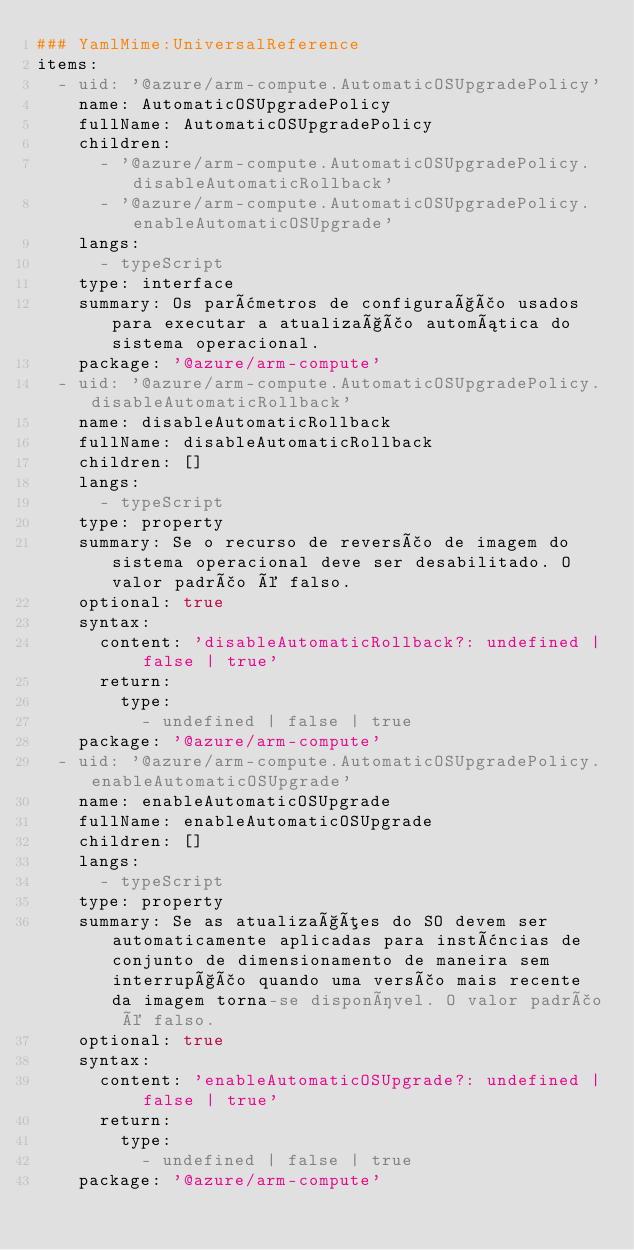<code> <loc_0><loc_0><loc_500><loc_500><_YAML_>### YamlMime:UniversalReference
items:
  - uid: '@azure/arm-compute.AutomaticOSUpgradePolicy'
    name: AutomaticOSUpgradePolicy
    fullName: AutomaticOSUpgradePolicy
    children:
      - '@azure/arm-compute.AutomaticOSUpgradePolicy.disableAutomaticRollback'
      - '@azure/arm-compute.AutomaticOSUpgradePolicy.enableAutomaticOSUpgrade'
    langs:
      - typeScript
    type: interface
    summary: Os parâmetros de configuração usados para executar a atualização automática do sistema operacional.
    package: '@azure/arm-compute'
  - uid: '@azure/arm-compute.AutomaticOSUpgradePolicy.disableAutomaticRollback'
    name: disableAutomaticRollback
    fullName: disableAutomaticRollback
    children: []
    langs:
      - typeScript
    type: property
    summary: Se o recurso de reversão de imagem do sistema operacional deve ser desabilitado. O valor padrão é falso.
    optional: true
    syntax:
      content: 'disableAutomaticRollback?: undefined | false | true'
      return:
        type:
          - undefined | false | true
    package: '@azure/arm-compute'
  - uid: '@azure/arm-compute.AutomaticOSUpgradePolicy.enableAutomaticOSUpgrade'
    name: enableAutomaticOSUpgrade
    fullName: enableAutomaticOSUpgrade
    children: []
    langs:
      - typeScript
    type: property
    summary: Se as atualizações do SO devem ser automaticamente aplicadas para instâncias de conjunto de dimensionamento de maneira sem interrupção quando uma versão mais recente da imagem torna-se disponível. O valor padrão é falso.
    optional: true
    syntax:
      content: 'enableAutomaticOSUpgrade?: undefined | false | true'
      return:
        type:
          - undefined | false | true
    package: '@azure/arm-compute'</code> 